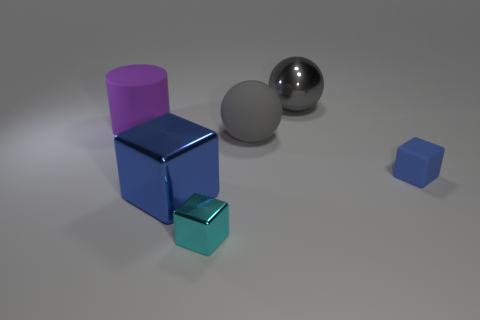What shape is the tiny blue object?
Keep it short and to the point. Cube. What shape is the large shiny object in front of the rubber object that is to the left of the big gray matte object?
Ensure brevity in your answer.  Cube. What is the material of the object that is the same color as the small rubber cube?
Offer a terse response. Metal. What color is the tiny block that is made of the same material as the big cylinder?
Make the answer very short. Blue. There is a sphere that is behind the gray rubber thing; does it have the same color as the big sphere in front of the purple object?
Your answer should be very brief. Yes. Are there more large shiny blocks in front of the big gray shiny ball than gray shiny objects in front of the small metallic thing?
Your answer should be very brief. Yes. What color is the rubber object that is the same shape as the tiny cyan shiny thing?
Give a very brief answer. Blue. Is there any other thing that has the same shape as the purple matte thing?
Provide a short and direct response. No. Does the small cyan object have the same shape as the blue thing to the left of the small cyan metal cube?
Offer a very short reply. Yes. What number of other things are made of the same material as the big purple object?
Offer a terse response. 2. 